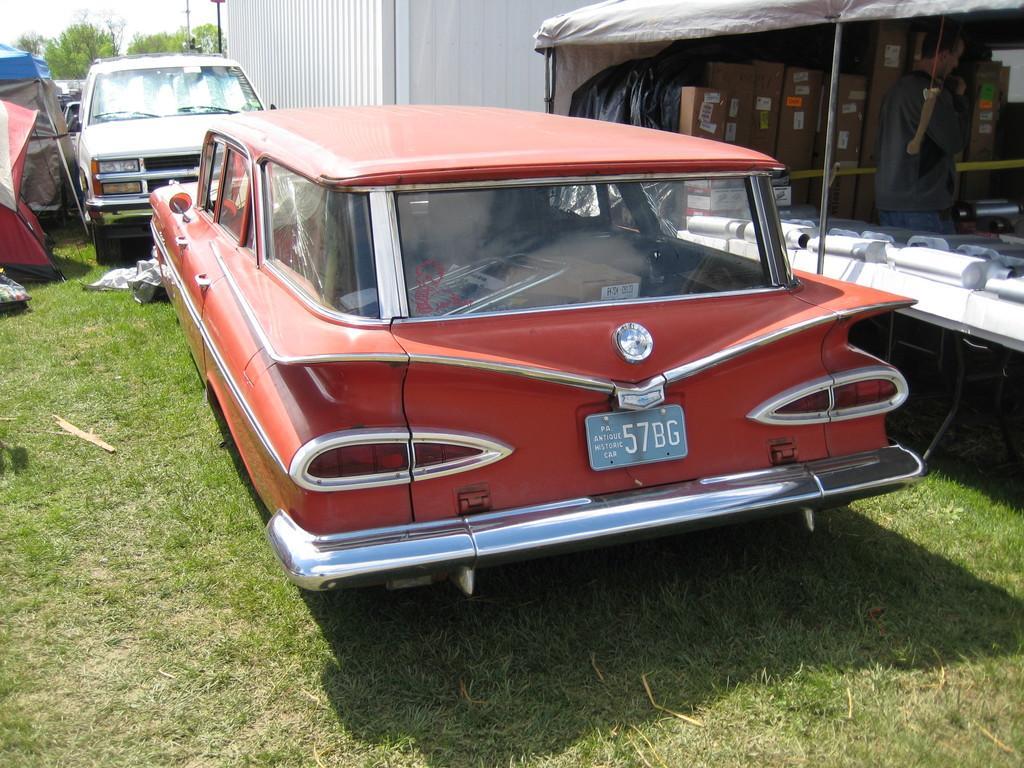Describe this image in one or two sentences. In this picture I can observe two cars parked on the ground in the middle of the picture. I can observe some grass on the ground. In the background there are trees. 